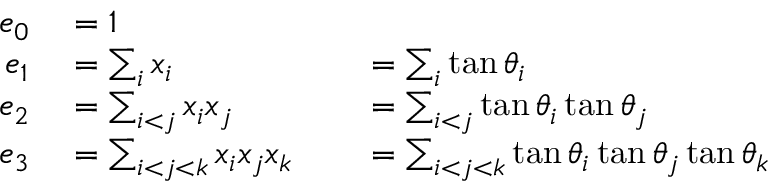Convert formula to latex. <formula><loc_0><loc_0><loc_500><loc_500>\begin{array} { r l r l } { e _ { 0 } } & = 1 } \\ { e _ { 1 } } & = \sum _ { i } x _ { i } } & = \sum _ { i } \tan \theta _ { i } } \\ { e _ { 2 } } & = \sum _ { i < j } x _ { i } x _ { j } } & = \sum _ { i < j } \tan \theta _ { i } \tan \theta _ { j } } \\ { e _ { 3 } } & = \sum _ { i < j < k } x _ { i } x _ { j } x _ { k } } & = \sum _ { i < j < k } \tan \theta _ { i } \tan \theta _ { j } \tan \theta _ { k } } \end{array}</formula> 